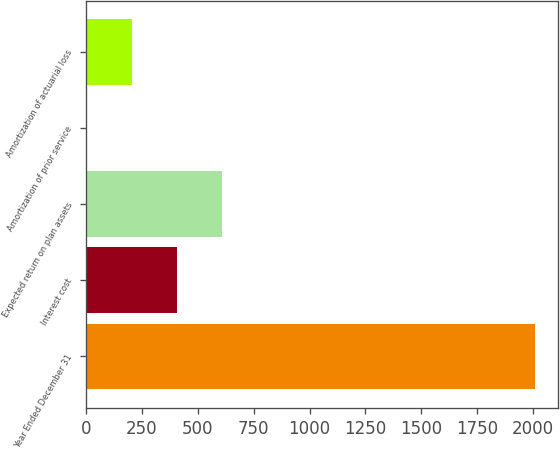Convert chart to OTSL. <chart><loc_0><loc_0><loc_500><loc_500><bar_chart><fcel>Year Ended December 31<fcel>Interest cost<fcel>Expected return on plan assets<fcel>Amortization of prior service<fcel>Amortization of actuarial loss<nl><fcel>2011<fcel>406.2<fcel>606.8<fcel>5<fcel>205.6<nl></chart> 